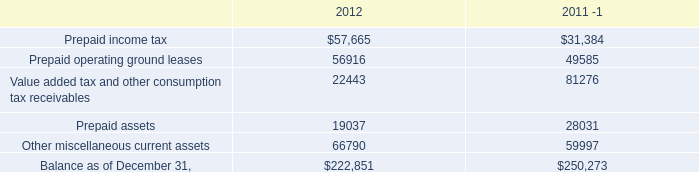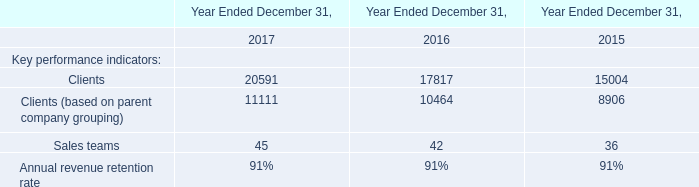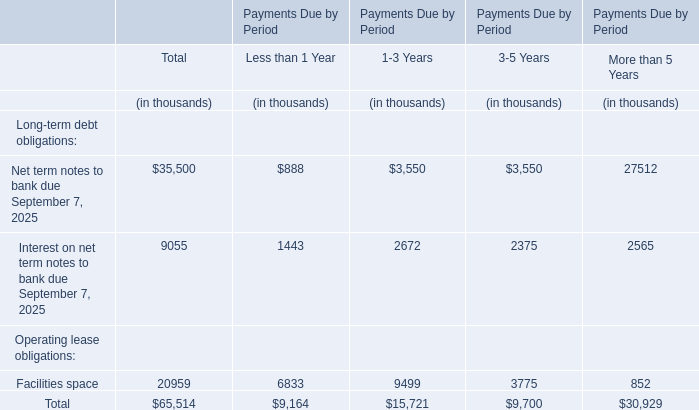What's the value of the Total Long-term debt obligations? (in thousand) 
Computations: (35500 + 9055)
Answer: 44555.0. 